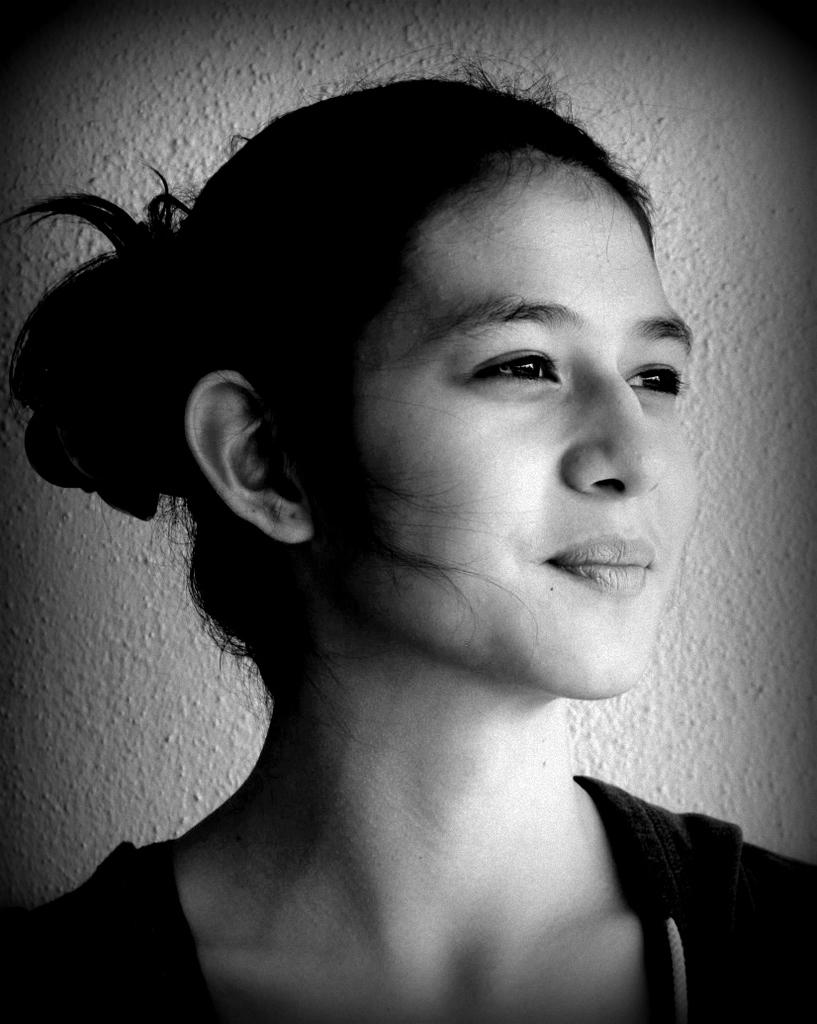What is the color scheme of the image? The image is black and white. Can you describe the main subject in the image? There is a person in the image. What can be seen in the background of the image? There is a wall in the background of the image. What type of toys can be seen on the calendar in the image? There is no calendar or toys present in the image. 